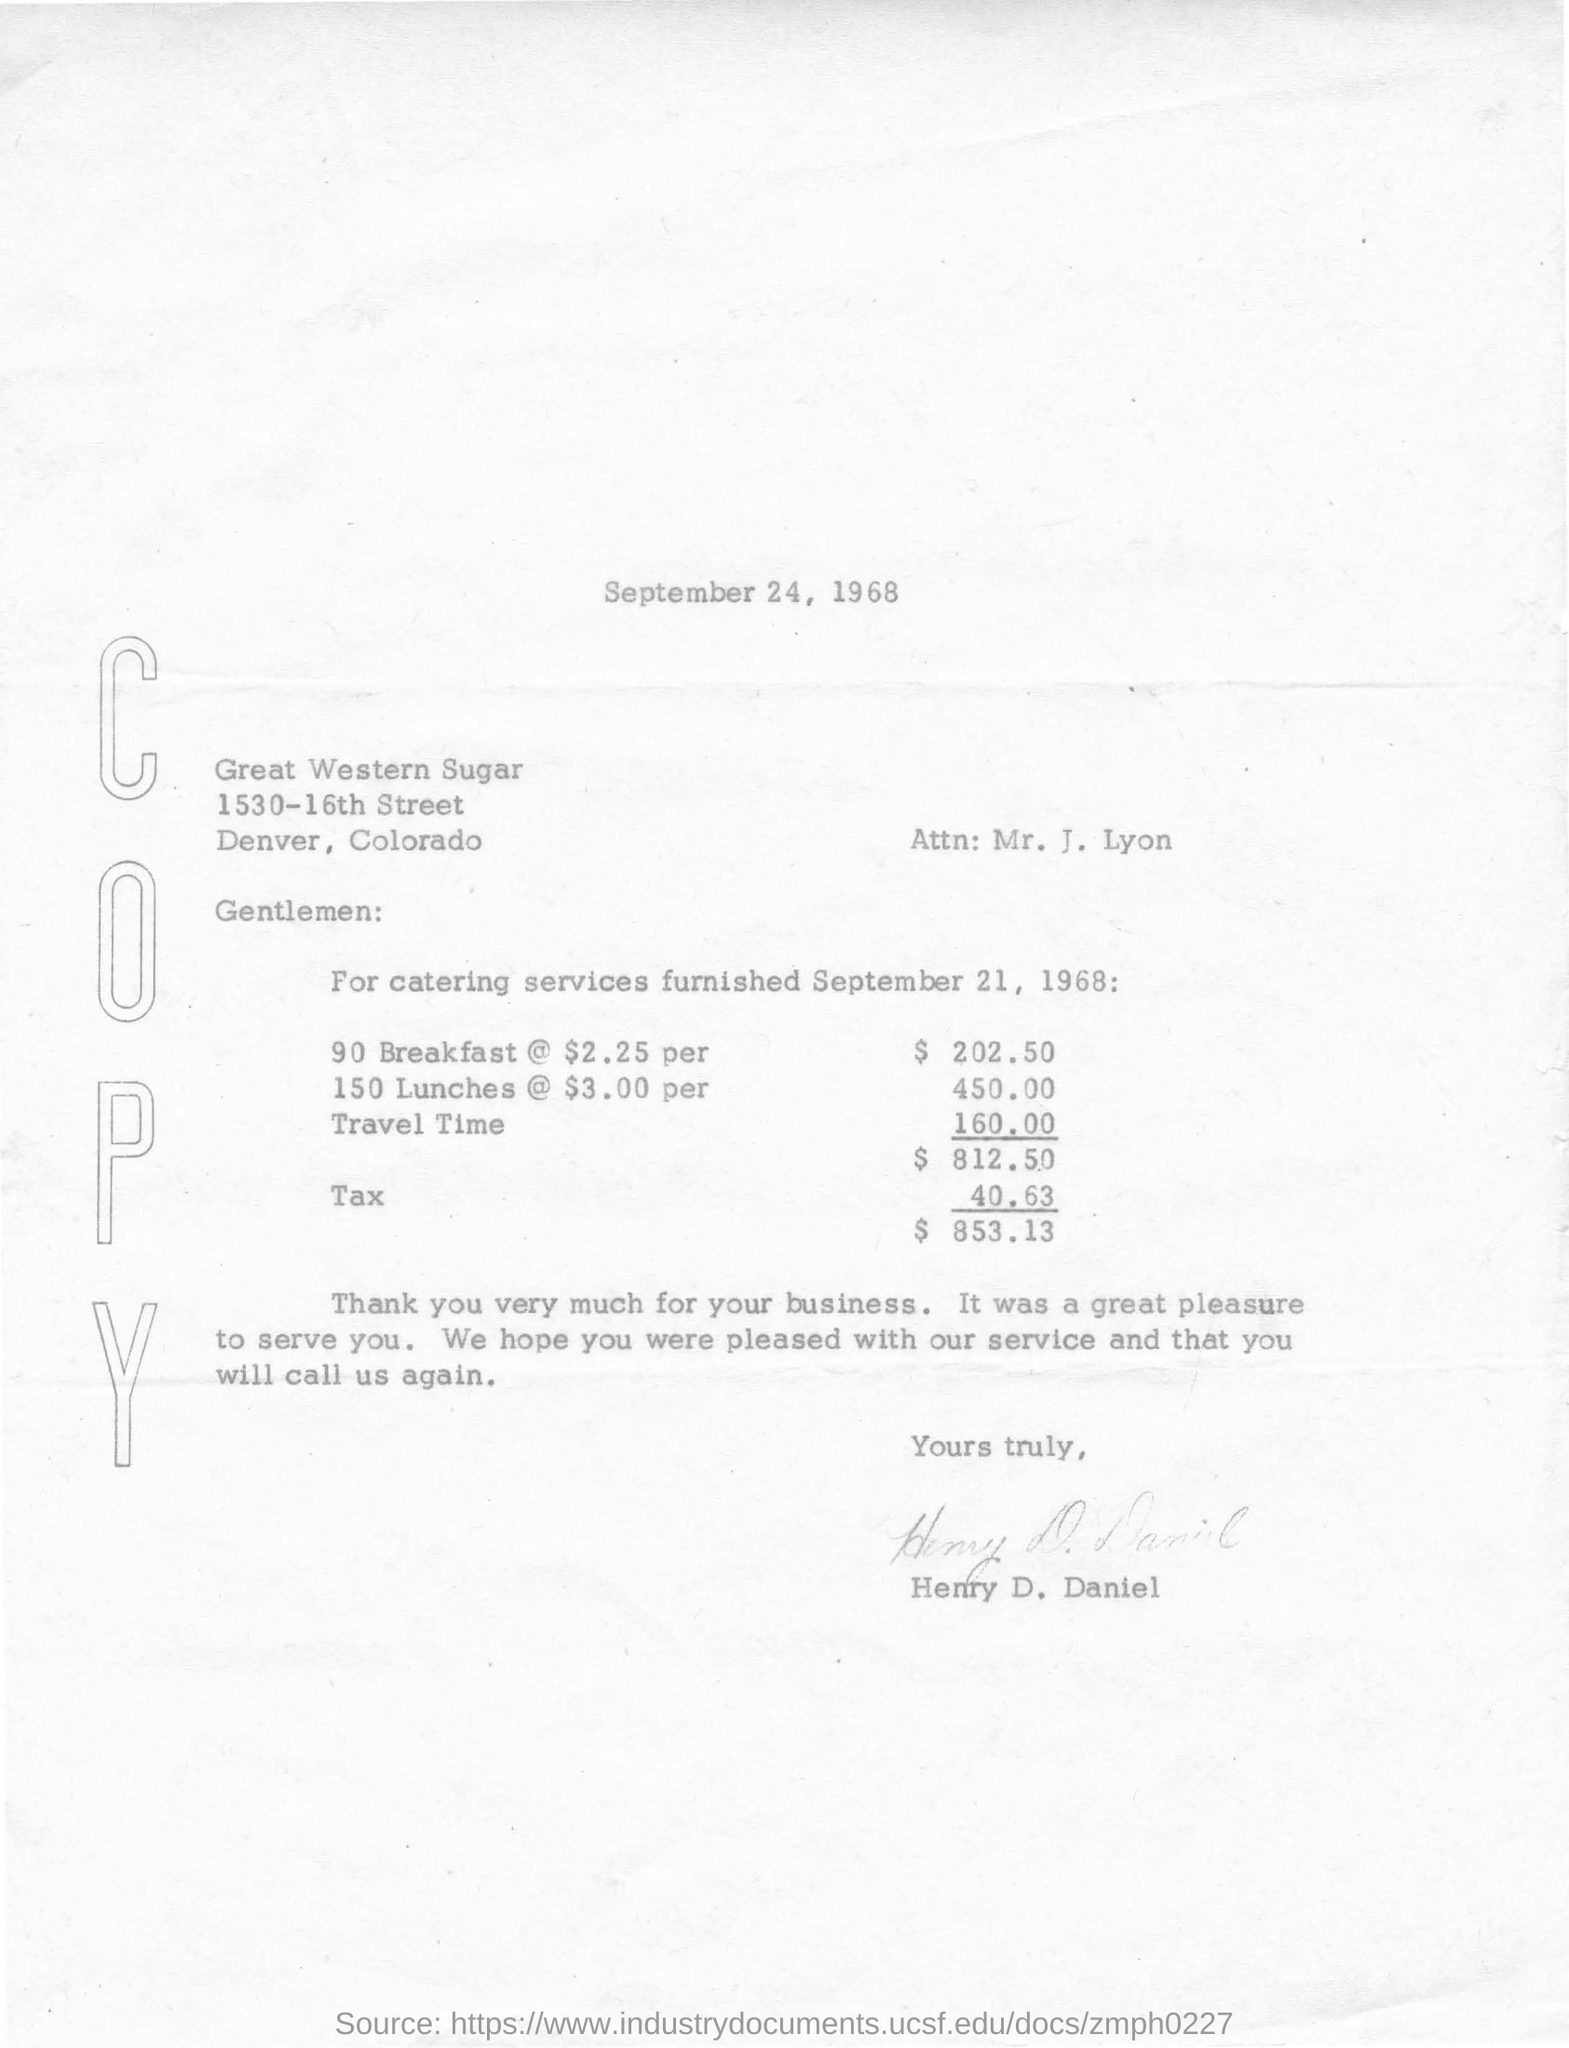What is the date mentioned in the top of the document?
Ensure brevity in your answer.  September 24, 1968. 